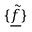<formula> <loc_0><loc_0><loc_500><loc_500>\{ \underline { { \tilde { f } } } \}</formula> 